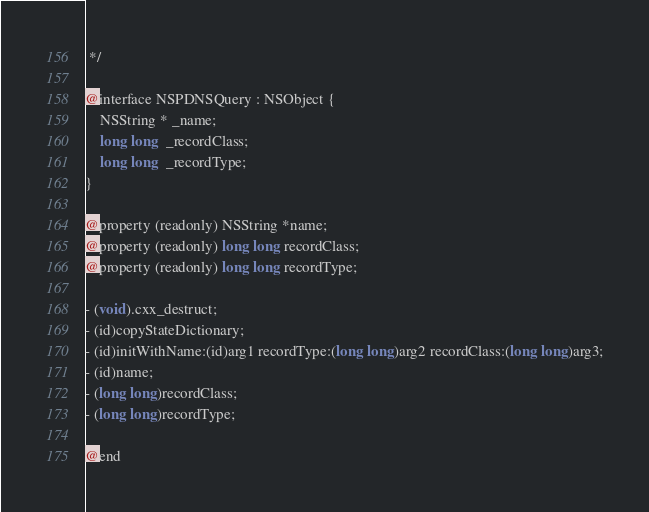Convert code to text. <code><loc_0><loc_0><loc_500><loc_500><_C_> */

@interface NSPDNSQuery : NSObject {
    NSString * _name;
    long long  _recordClass;
    long long  _recordType;
}

@property (readonly) NSString *name;
@property (readonly) long long recordClass;
@property (readonly) long long recordType;

- (void).cxx_destruct;
- (id)copyStateDictionary;
- (id)initWithName:(id)arg1 recordType:(long long)arg2 recordClass:(long long)arg3;
- (id)name;
- (long long)recordClass;
- (long long)recordType;

@end
</code> 